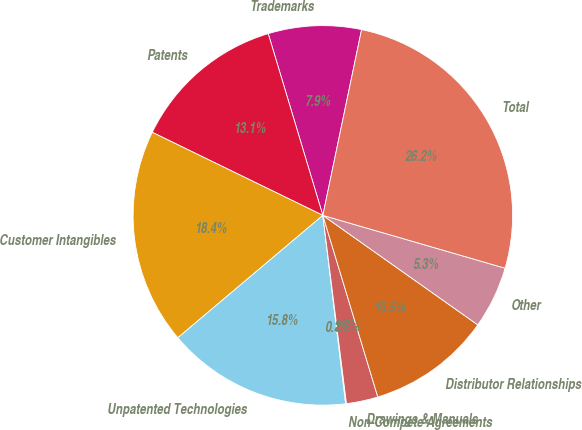Convert chart to OTSL. <chart><loc_0><loc_0><loc_500><loc_500><pie_chart><fcel>Trademarks<fcel>Patents<fcel>Customer Intangibles<fcel>Unpatented Technologies<fcel>Non-Compete Agreements<fcel>Drawings & Manuals<fcel>Distributor Relationships<fcel>Other<fcel>Total<nl><fcel>7.92%<fcel>13.14%<fcel>18.37%<fcel>15.76%<fcel>0.07%<fcel>2.69%<fcel>10.53%<fcel>5.3%<fcel>26.22%<nl></chart> 